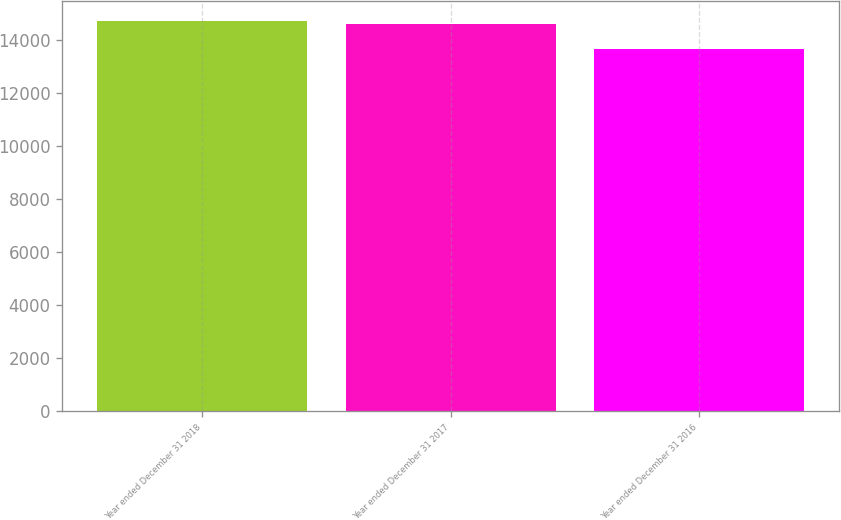<chart> <loc_0><loc_0><loc_500><loc_500><bar_chart><fcel>Year ended December 31 2018<fcel>Year ended December 31 2017<fcel>Year ended December 31 2016<nl><fcel>14707<fcel>14600<fcel>13636<nl></chart> 